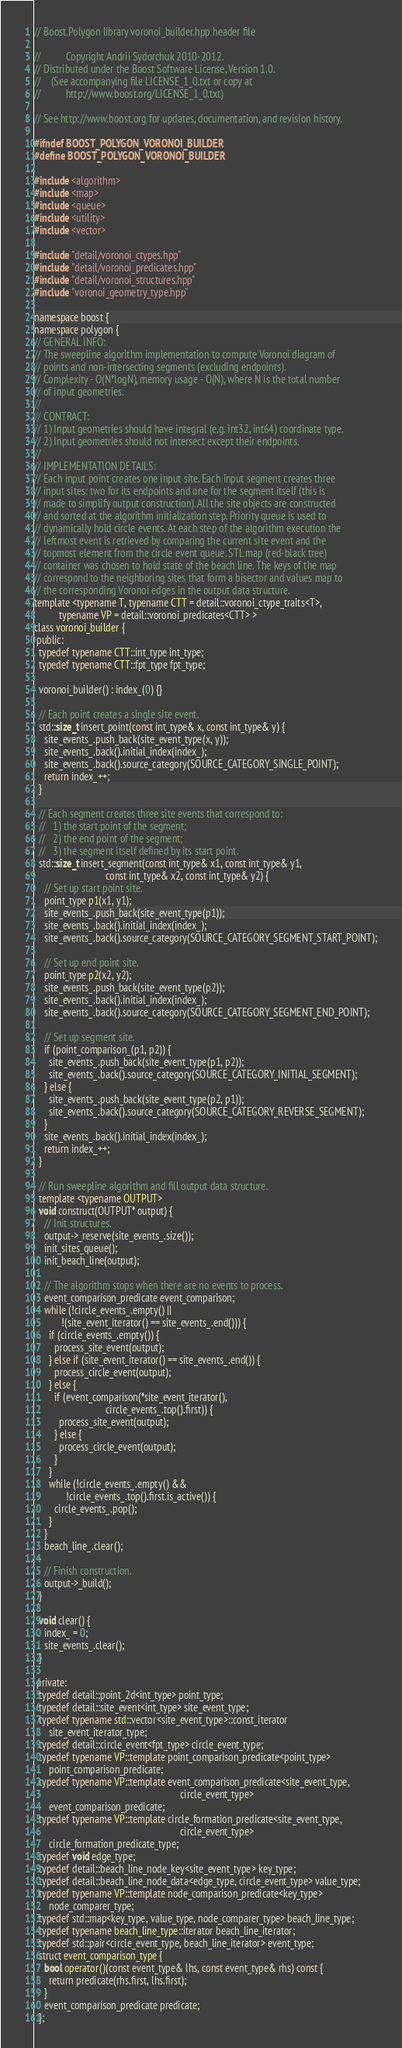Convert code to text. <code><loc_0><loc_0><loc_500><loc_500><_C++_>// Boost.Polygon library voronoi_builder.hpp header file

//          Copyright Andrii Sydorchuk 2010-2012.
// Distributed under the Boost Software License, Version 1.0.
//    (See accompanying file LICENSE_1_0.txt or copy at
//          http://www.boost.org/LICENSE_1_0.txt)

// See http://www.boost.org for updates, documentation, and revision history.

#ifndef BOOST_POLYGON_VORONOI_BUILDER
#define BOOST_POLYGON_VORONOI_BUILDER

#include <algorithm>
#include <map>
#include <queue>
#include <utility>
#include <vector>

#include "detail/voronoi_ctypes.hpp"
#include "detail/voronoi_predicates.hpp"
#include "detail/voronoi_structures.hpp"
#include "voronoi_geometry_type.hpp"

namespace boost {
namespace polygon {
// GENERAL INFO:
// The sweepline algorithm implementation to compute Voronoi diagram of
// points and non-intersecting segments (excluding endpoints).
// Complexity - O(N*logN), memory usage - O(N), where N is the total number
// of input geometries.
//
// CONTRACT:
// 1) Input geometries should have integral (e.g. int32, int64) coordinate type.
// 2) Input geometries should not intersect except their endpoints.
//
// IMPLEMENTATION DETAILS:
// Each input point creates one input site. Each input segment creates three
// input sites: two for its endpoints and one for the segment itself (this is
// made to simplify output construction). All the site objects are constructed
// and sorted at the algorithm initialization step. Priority queue is used to
// dynamically hold circle events. At each step of the algorithm execution the
// leftmost event is retrieved by comparing the current site event and the
// topmost element from the circle event queue. STL map (red-black tree)
// container was chosen to hold state of the beach line. The keys of the map
// correspond to the neighboring sites that form a bisector and values map to
// the corresponding Voronoi edges in the output data structure.
template <typename T, typename CTT = detail::voronoi_ctype_traits<T>,
          typename VP = detail::voronoi_predicates<CTT> >
class voronoi_builder {
 public:
  typedef typename CTT::int_type int_type;
  typedef typename CTT::fpt_type fpt_type;

  voronoi_builder() : index_(0) {}

  // Each point creates a single site event.
  std::size_t insert_point(const int_type& x, const int_type& y) {
    site_events_.push_back(site_event_type(x, y));
    site_events_.back().initial_index(index_);
    site_events_.back().source_category(SOURCE_CATEGORY_SINGLE_POINT);
    return index_++;
  }

  // Each segment creates three site events that correspond to:
  //   1) the start point of the segment;
  //   2) the end point of the segment;
  //   3) the segment itself defined by its start point.
  std::size_t insert_segment(const int_type& x1, const int_type& y1,
                             const int_type& x2, const int_type& y2) {
    // Set up start point site.
    point_type p1(x1, y1);
    site_events_.push_back(site_event_type(p1));
    site_events_.back().initial_index(index_);
    site_events_.back().source_category(SOURCE_CATEGORY_SEGMENT_START_POINT);

    // Set up end point site.
    point_type p2(x2, y2);
    site_events_.push_back(site_event_type(p2));
    site_events_.back().initial_index(index_);
    site_events_.back().source_category(SOURCE_CATEGORY_SEGMENT_END_POINT);

    // Set up segment site.
    if (point_comparison_(p1, p2)) {
      site_events_.push_back(site_event_type(p1, p2));
      site_events_.back().source_category(SOURCE_CATEGORY_INITIAL_SEGMENT);
    } else {
      site_events_.push_back(site_event_type(p2, p1));
      site_events_.back().source_category(SOURCE_CATEGORY_REVERSE_SEGMENT);
    }
    site_events_.back().initial_index(index_);
    return index_++;
  }

  // Run sweepline algorithm and fill output data structure.
  template <typename OUTPUT>
  void construct(OUTPUT* output) {
    // Init structures.
    output->_reserve(site_events_.size());
    init_sites_queue();
    init_beach_line(output);

    // The algorithm stops when there are no events to process.
    event_comparison_predicate event_comparison;
    while (!circle_events_.empty() ||
           !(site_event_iterator() == site_events_.end())) {
      if (circle_events_.empty()) {
        process_site_event(output);
      } else if (site_event_iterator() == site_events_.end()) {
        process_circle_event(output);
      } else {
        if (event_comparison(*site_event_iterator(),
                             circle_events_.top().first)) {
          process_site_event(output);
        } else {
          process_circle_event(output);
        }
      }
      while (!circle_events_.empty() &&
             !circle_events_.top().first.is_active()) {
        circle_events_.pop();
      }
    }
    beach_line_.clear();

    // Finish construction.
    output->_build();
  }

  void clear() {
    index_ = 0;
    site_events_.clear();
  }

 private:
  typedef detail::point_2d<int_type> point_type;
  typedef detail::site_event<int_type> site_event_type;
  typedef typename std::vector<site_event_type>::const_iterator
      site_event_iterator_type;
  typedef detail::circle_event<fpt_type> circle_event_type;
  typedef typename VP::template point_comparison_predicate<point_type>
      point_comparison_predicate;
  typedef typename VP::template event_comparison_predicate<site_event_type,
                                                           circle_event_type>
      event_comparison_predicate;
  typedef typename VP::template circle_formation_predicate<site_event_type,
                                                           circle_event_type>
      circle_formation_predicate_type;
  typedef void edge_type;
  typedef detail::beach_line_node_key<site_event_type> key_type;
  typedef detail::beach_line_node_data<edge_type, circle_event_type> value_type;
  typedef typename VP::template node_comparison_predicate<key_type>
      node_comparer_type;
  typedef std::map<key_type, value_type, node_comparer_type> beach_line_type;
  typedef typename beach_line_type::iterator beach_line_iterator;
  typedef std::pair<circle_event_type, beach_line_iterator> event_type;
  struct event_comparison_type {
    bool operator()(const event_type& lhs, const event_type& rhs) const {
      return predicate(rhs.first, lhs.first);
    }
    event_comparison_predicate predicate;
  };</code> 